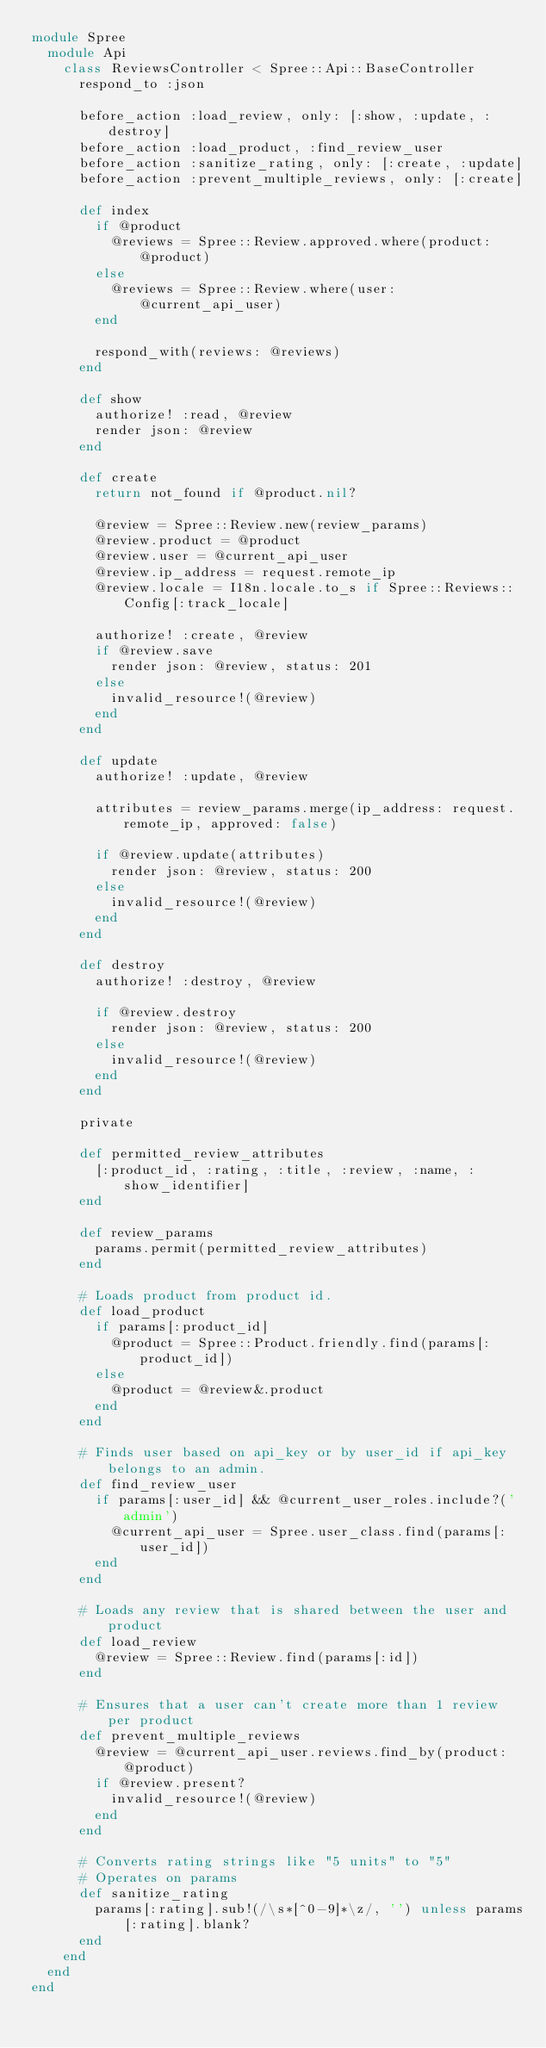Convert code to text. <code><loc_0><loc_0><loc_500><loc_500><_Ruby_>module Spree
  module Api
    class ReviewsController < Spree::Api::BaseController
      respond_to :json

      before_action :load_review, only: [:show, :update, :destroy]
      before_action :load_product, :find_review_user
      before_action :sanitize_rating, only: [:create, :update]
      before_action :prevent_multiple_reviews, only: [:create]

      def index
        if @product
          @reviews = Spree::Review.approved.where(product: @product)
        else
          @reviews = Spree::Review.where(user: @current_api_user)
        end

        respond_with(reviews: @reviews)
      end

      def show
        authorize! :read, @review
        render json: @review
      end

      def create
        return not_found if @product.nil?

        @review = Spree::Review.new(review_params)
        @review.product = @product
        @review.user = @current_api_user
        @review.ip_address = request.remote_ip
        @review.locale = I18n.locale.to_s if Spree::Reviews::Config[:track_locale]

        authorize! :create, @review
        if @review.save
          render json: @review, status: 201
        else
          invalid_resource!(@review)
        end
      end

      def update
        authorize! :update, @review

        attributes = review_params.merge(ip_address: request.remote_ip, approved: false)

        if @review.update(attributes)
          render json: @review, status: 200
        else
          invalid_resource!(@review)
        end
      end

      def destroy
        authorize! :destroy, @review

        if @review.destroy
          render json: @review, status: 200
        else
          invalid_resource!(@review)
        end
      end

      private

      def permitted_review_attributes
        [:product_id, :rating, :title, :review, :name, :show_identifier]
      end

      def review_params
        params.permit(permitted_review_attributes)
      end

      # Loads product from product id.
      def load_product
        if params[:product_id]
          @product = Spree::Product.friendly.find(params[:product_id])
        else
          @product = @review&.product
        end
      end

      # Finds user based on api_key or by user_id if api_key belongs to an admin.
      def find_review_user
        if params[:user_id] && @current_user_roles.include?('admin')
          @current_api_user = Spree.user_class.find(params[:user_id])
        end
      end

      # Loads any review that is shared between the user and product
      def load_review
        @review = Spree::Review.find(params[:id])
      end

      # Ensures that a user can't create more than 1 review per product
      def prevent_multiple_reviews
        @review = @current_api_user.reviews.find_by(product: @product)
        if @review.present?
          invalid_resource!(@review)
        end
      end

      # Converts rating strings like "5 units" to "5"
      # Operates on params
      def sanitize_rating
        params[:rating].sub!(/\s*[^0-9]*\z/, '') unless params[:rating].blank?
      end
    end
  end
end
</code> 